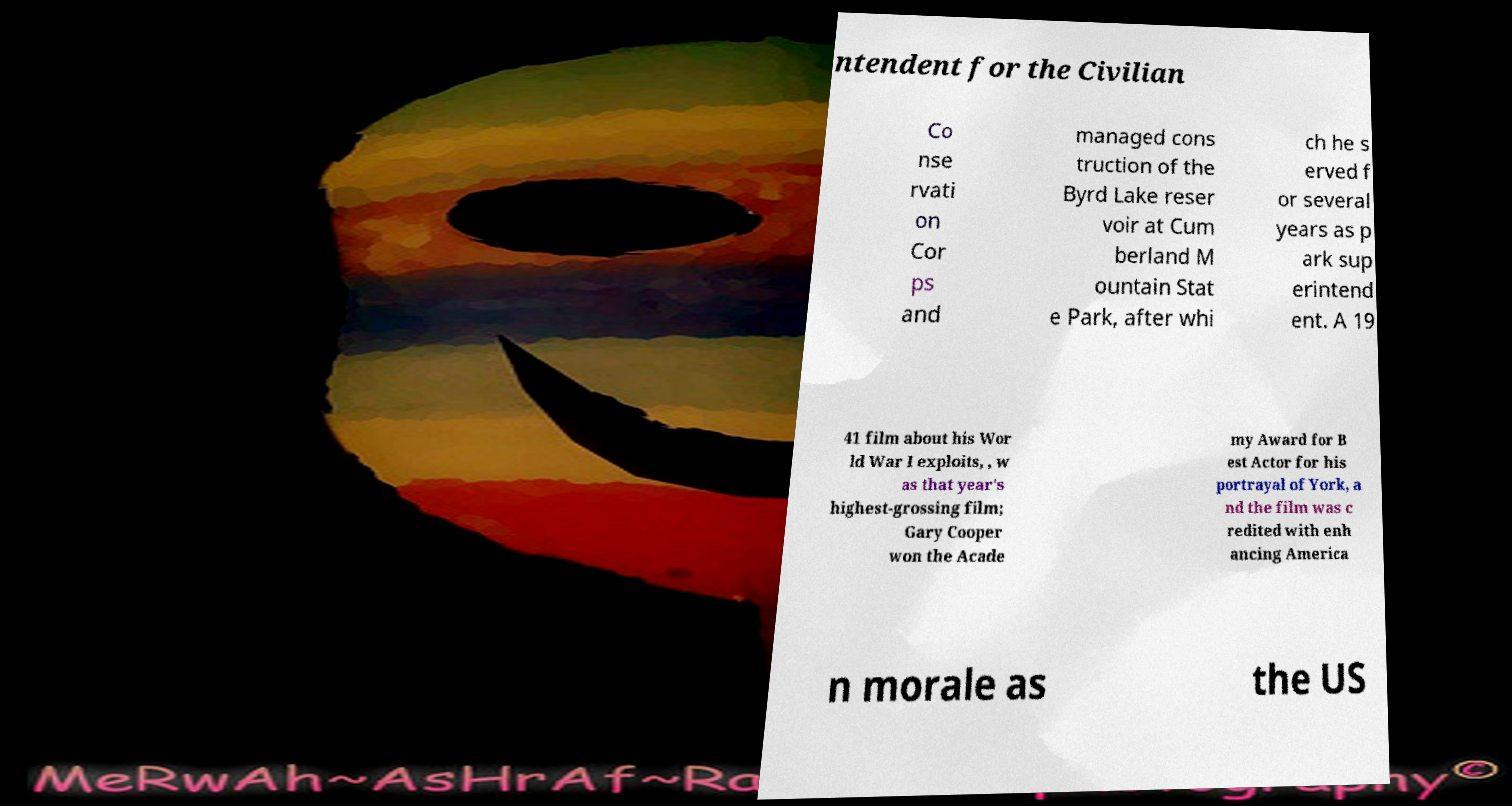Could you extract and type out the text from this image? ntendent for the Civilian Co nse rvati on Cor ps and managed cons truction of the Byrd Lake reser voir at Cum berland M ountain Stat e Park, after whi ch he s erved f or several years as p ark sup erintend ent. A 19 41 film about his Wor ld War I exploits, , w as that year's highest-grossing film; Gary Cooper won the Acade my Award for B est Actor for his portrayal of York, a nd the film was c redited with enh ancing America n morale as the US 